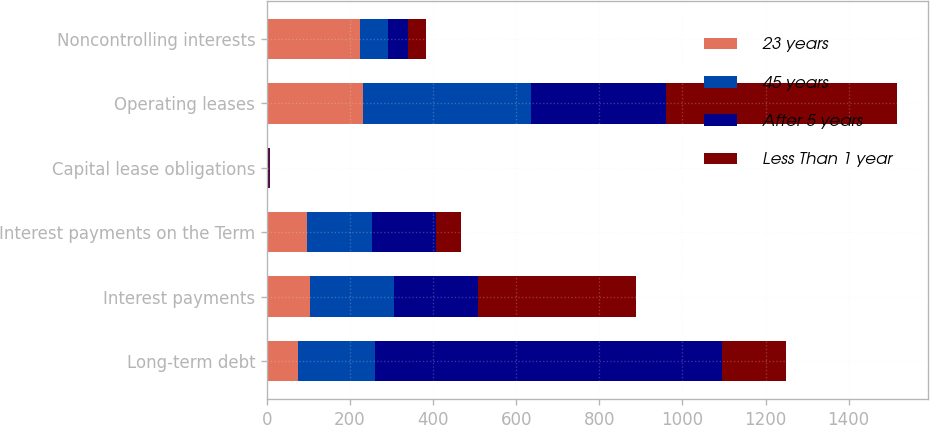<chart> <loc_0><loc_0><loc_500><loc_500><stacked_bar_chart><ecel><fcel>Long-term debt<fcel>Interest payments<fcel>Interest payments on the Term<fcel>Capital lease obligations<fcel>Operating leases<fcel>Noncontrolling interests<nl><fcel>23 years<fcel>74<fcel>104<fcel>96<fcel>1<fcel>232<fcel>225<nl><fcel>45 years<fcel>186<fcel>202<fcel>157<fcel>2<fcel>403<fcel>67<nl><fcel>After 5 years<fcel>835<fcel>202<fcel>153<fcel>1<fcel>326<fcel>48<nl><fcel>Less Than 1 year<fcel>153<fcel>379<fcel>61<fcel>4<fcel>555<fcel>43<nl></chart> 